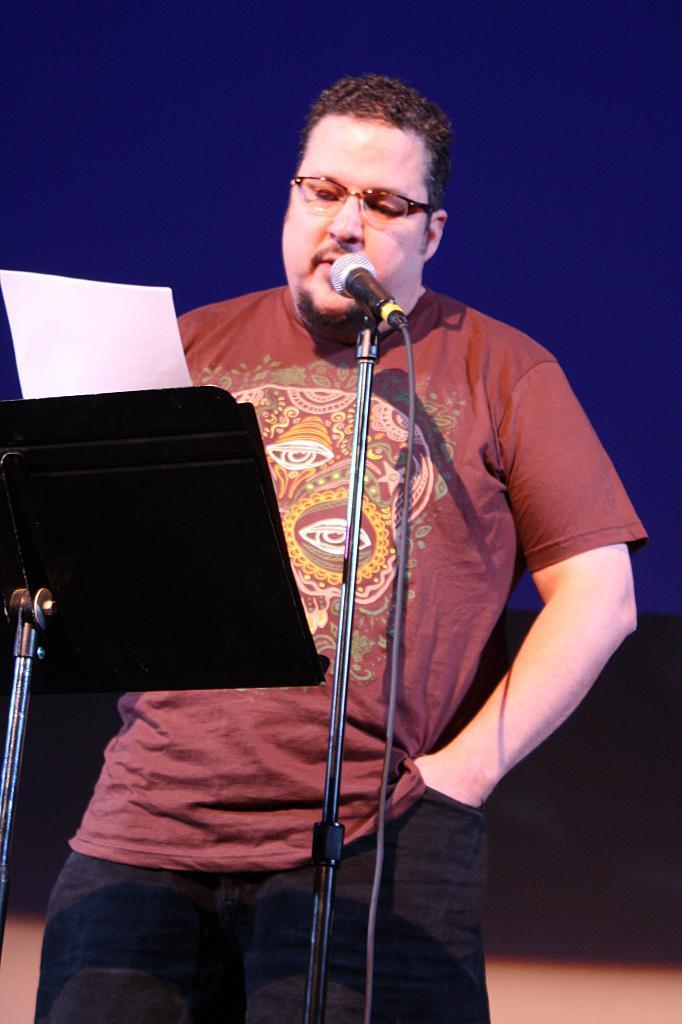Could you give a brief overview of what you see in this image? In this image in the foreground I can see a man standing and reading some paper and there is a mike in front of him. 